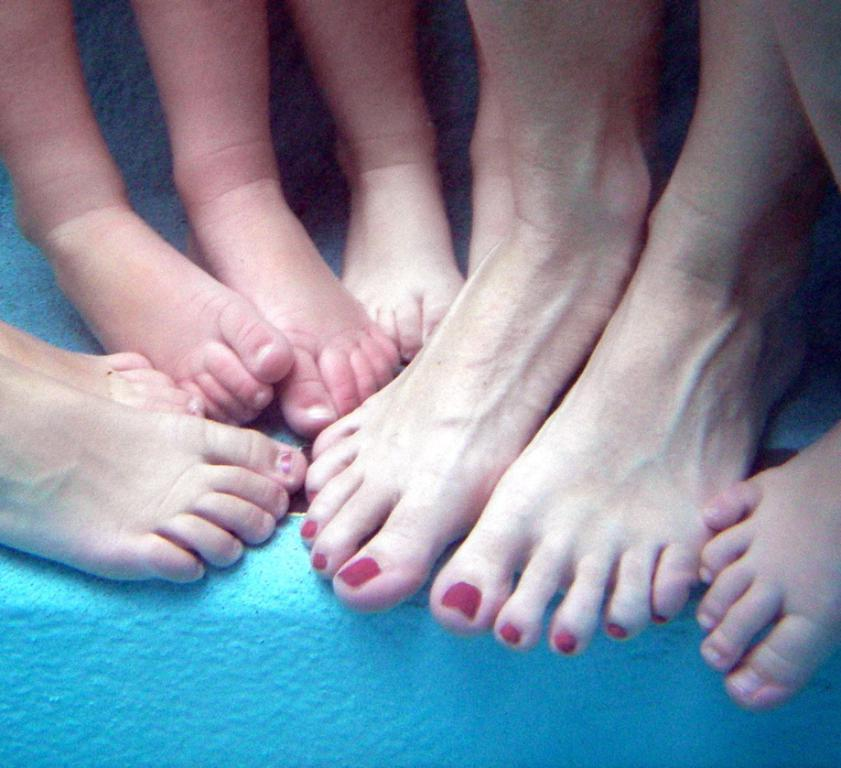What body parts are visible in the image? There are people's legs visible in the image. What color is the surface beneath the legs? The surface beneath the legs is blue. Are there any volcanoes visible in the image? No, there are no volcanoes present in the image. Can you see any waves in the image? No, there are no waves present in the image. 